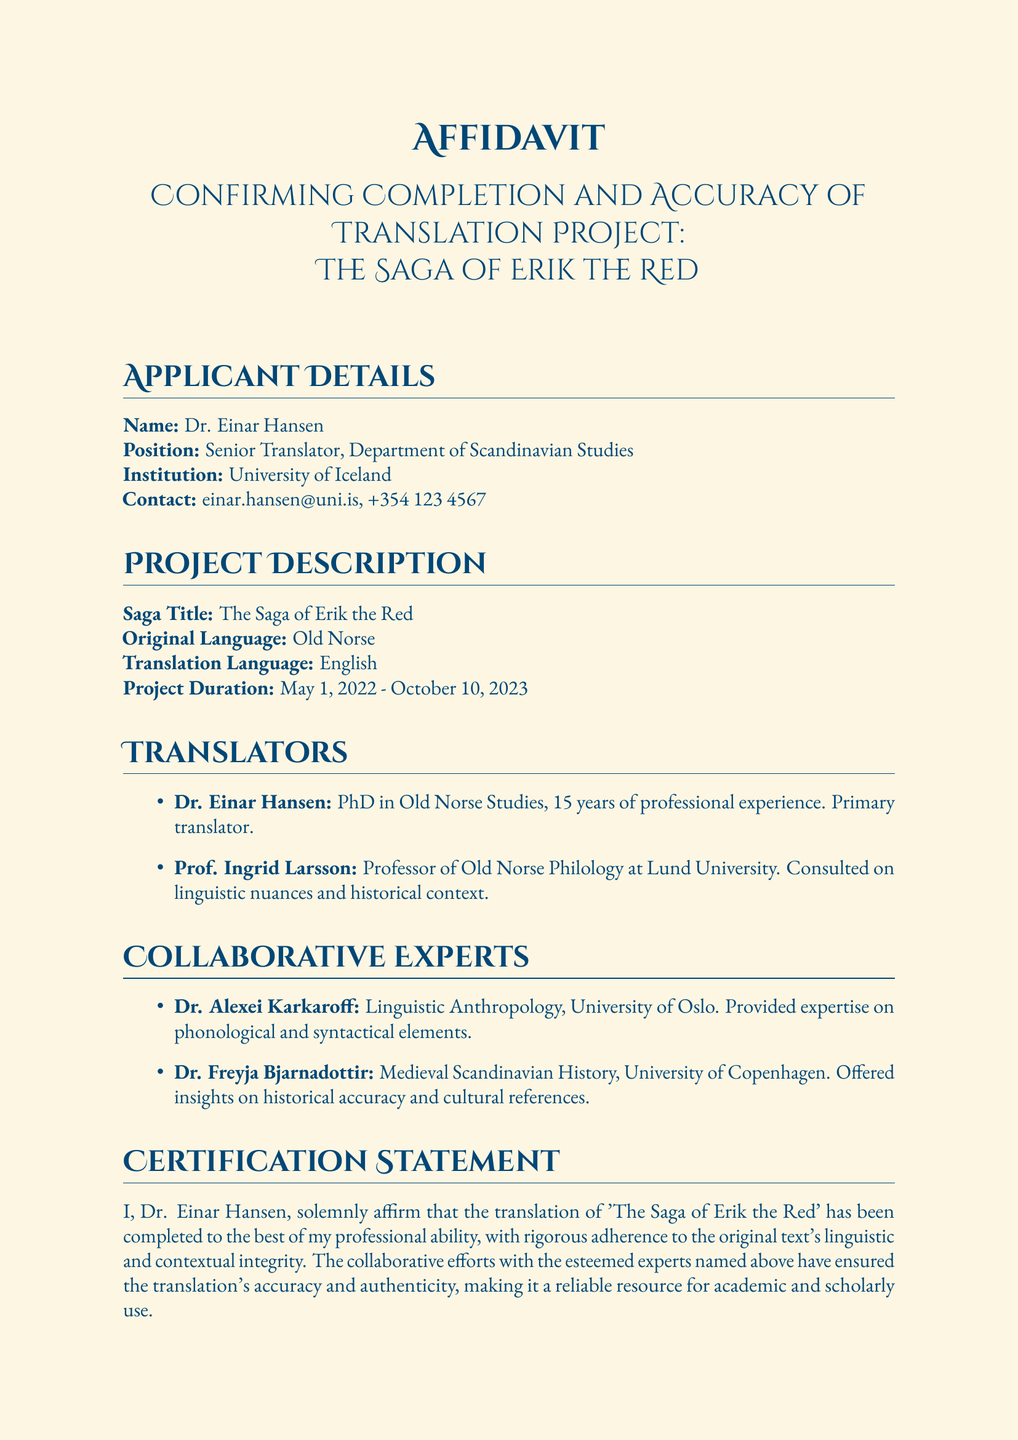What is the name of the applicant? The applicant's name is found in the "Applicant Details" section.
Answer: Dr. Einar Hansen What position does the applicant hold? The position of the applicant is specified in the "Applicant Details" section.
Answer: Senior Translator What is the original language of the saga? The original language is mentioned in the "Project Description" section.
Answer: Old Norse What is the project duration? The project duration is detailed in the "Project Description" section.
Answer: May 1, 2022 - October 10, 2023 Who is the primary translator? The primary translator is listed under the "Translators" section.
Answer: Dr. Einar Hansen Which professor consulted on linguistic nuances? The name of the professor is included in the "Translators" section.
Answer: Prof. Ingrid Larsson How many years of experience does Dr. Einar Hansen have? The years of experience are stated in the "Translators" section.
Answer: 15 years Name one area of expertise provided by Dr. Alexei Karkaroff. The expertise is mentioned in the "Collaborative Experts" section.
Answer: Linguistic Anthropology What does Dr. Einar Hansen affirm about the translation? The affirmation is presented in the "Certification Statement" section.
Answer: Accuracy and authenticity 